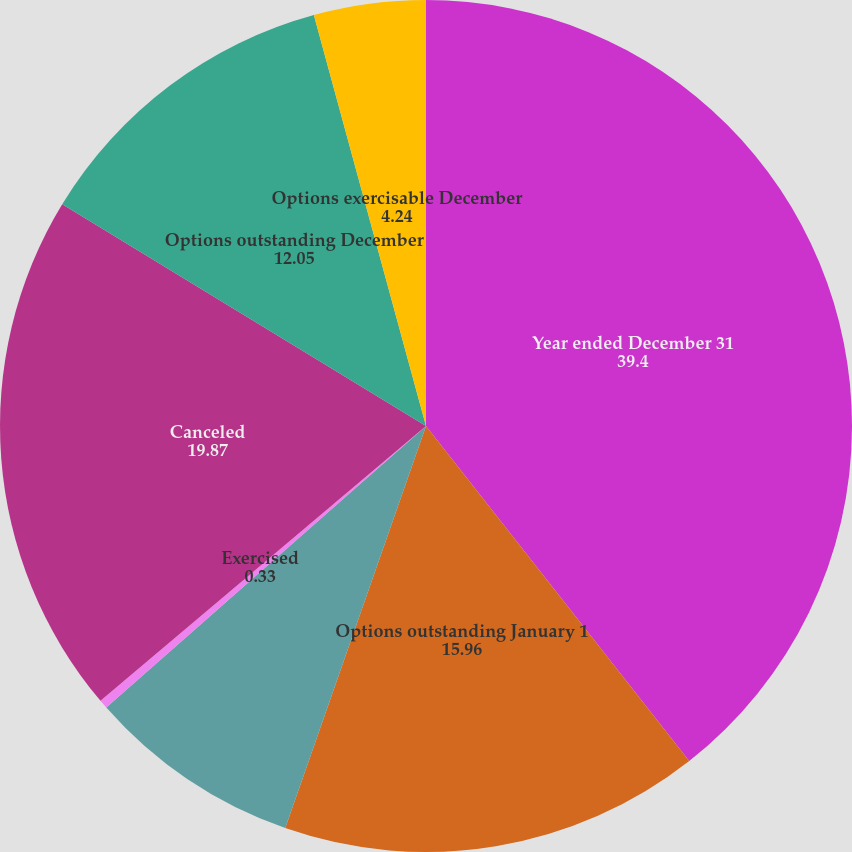Convert chart. <chart><loc_0><loc_0><loc_500><loc_500><pie_chart><fcel>Year ended December 31<fcel>Options outstanding January 1<fcel>Granted<fcel>Exercised<fcel>Canceled<fcel>Options outstanding December<fcel>Options exercisable December<nl><fcel>39.4%<fcel>15.96%<fcel>8.15%<fcel>0.33%<fcel>19.87%<fcel>12.05%<fcel>4.24%<nl></chart> 